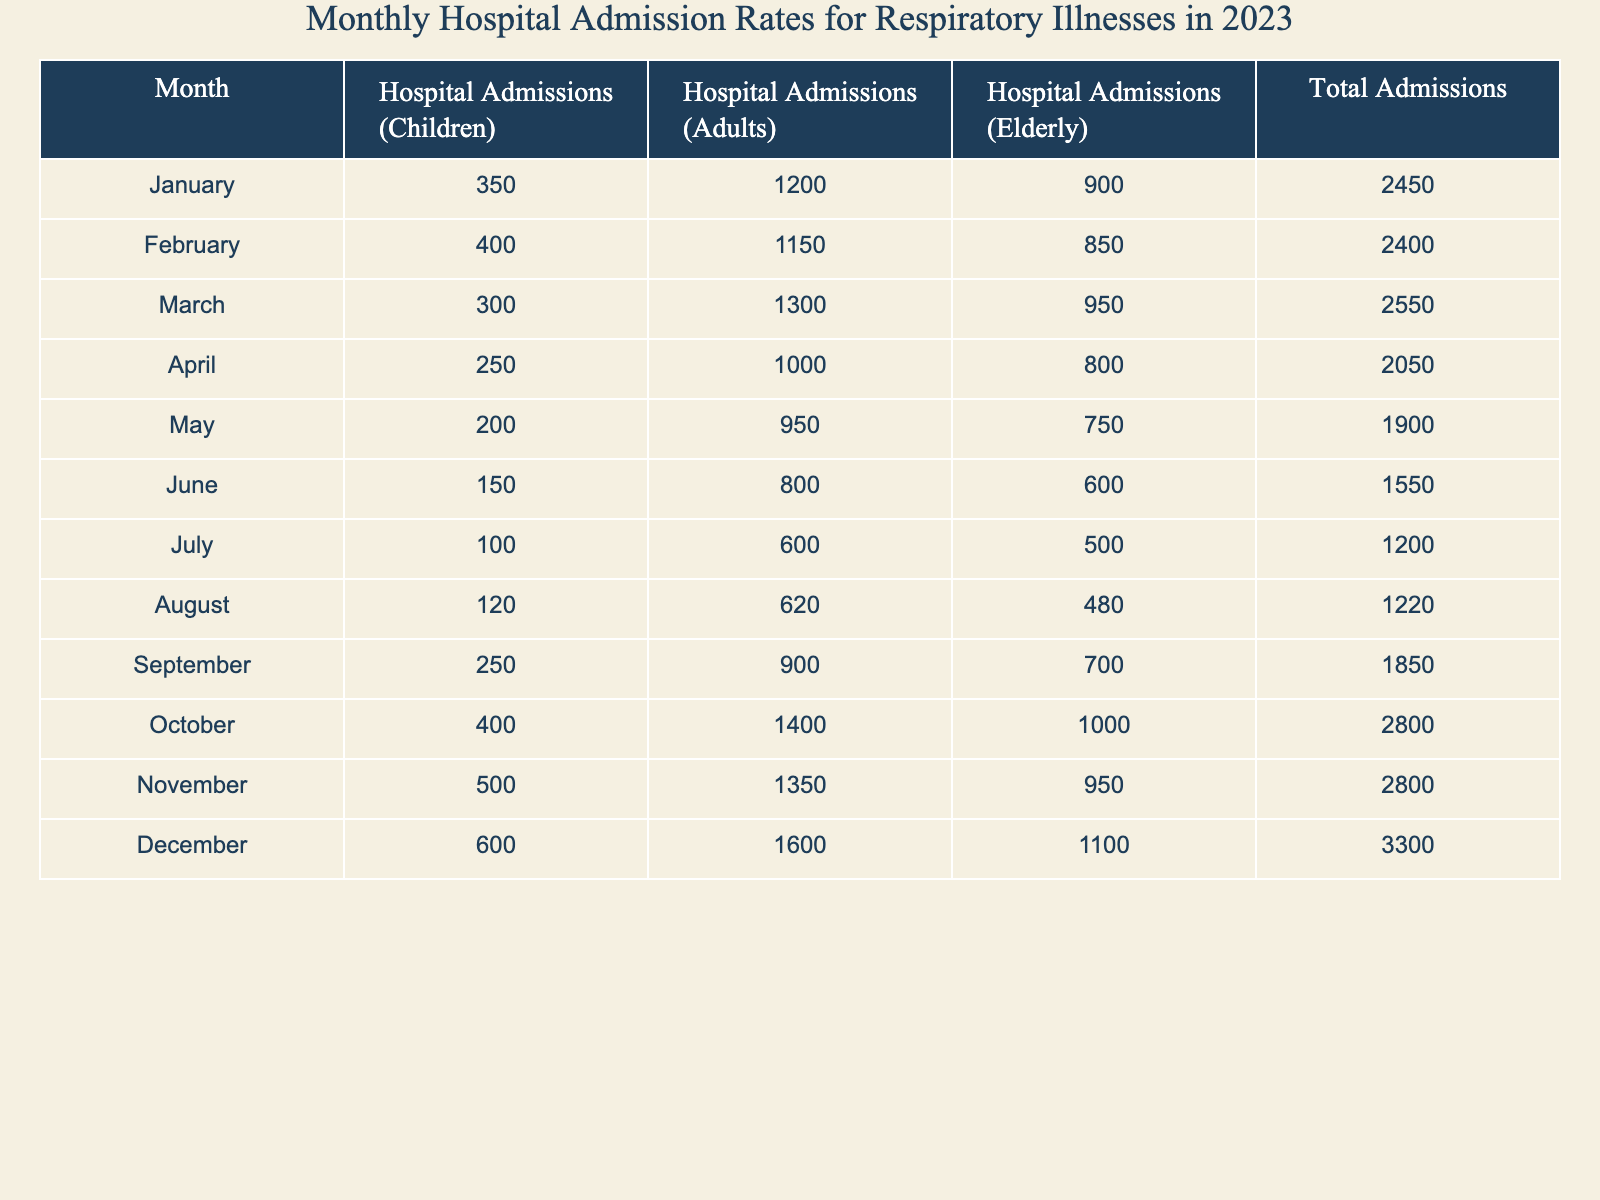What was the total number of hospital admissions in December? The table lists December's total admissions as 3300.
Answer: 3300 What month had the highest hospital admissions for elderly patients? The highest hospital admissions for elderly patients were in December, with 1100 admissions.
Answer: December What is the average number of hospital admissions for children across the year? To find the average, sum the admissions for children for each month (350 + 400 + 300 + 250 + 200 + 150 + 100 + 120 + 250 + 400 + 500 + 600 =  3250), then divide by the number of months (12), resulting in an average of 3250/12 ≈ 270.83.
Answer: Approximately 270.83 In which month did the number of hospital admissions for adults exceed 1300? The months where adult admissions exceeded 1300 are March, October, and November.
Answer: March, October, November What was the change in total admissions from January to July? The total admissions in January were 2450 and in July they were 1200. The change is 1200 - 2450 = -1250, indicating a decrease.
Answer: Decrease of 1250 Which age group had the lowest number of hospital admissions in June? In June, children had 150 admissions, adults had 800, and elderly had 600. Therefore, children had the lowest number of admissions.
Answer: Children Which month had the lowest hospital admissions overall, and what was that total? April had the lowest overall hospital admissions, with a total of 2050.
Answer: April, 2050 How many more admissions for the elderly were there in October compared to August? October had 1000 elderly admissions and August had 480. The difference is 1000 - 480 = 520 additional admissions for elderly in October.
Answer: 520 If you combine hospital admissions for children and adults in February, what is the total? In February, children had 400 and adults had 1150. The total is 400 + 1150 = 1550.
Answer: 1550 Was the total number of hospital admissions in November greater than in June? In November, total admissions were 2800, while in June they were 1550. Since 2800 > 1550, the statement is true.
Answer: Yes What is the monthly average of hospital admissions for adults from January to March? The total for adults from January to March is 1200 + 1150 + 1300 = 3650, and dividing that by 3 gives an average of 3650/3 ≈ 1216.67.
Answer: Approximately 1216.67 